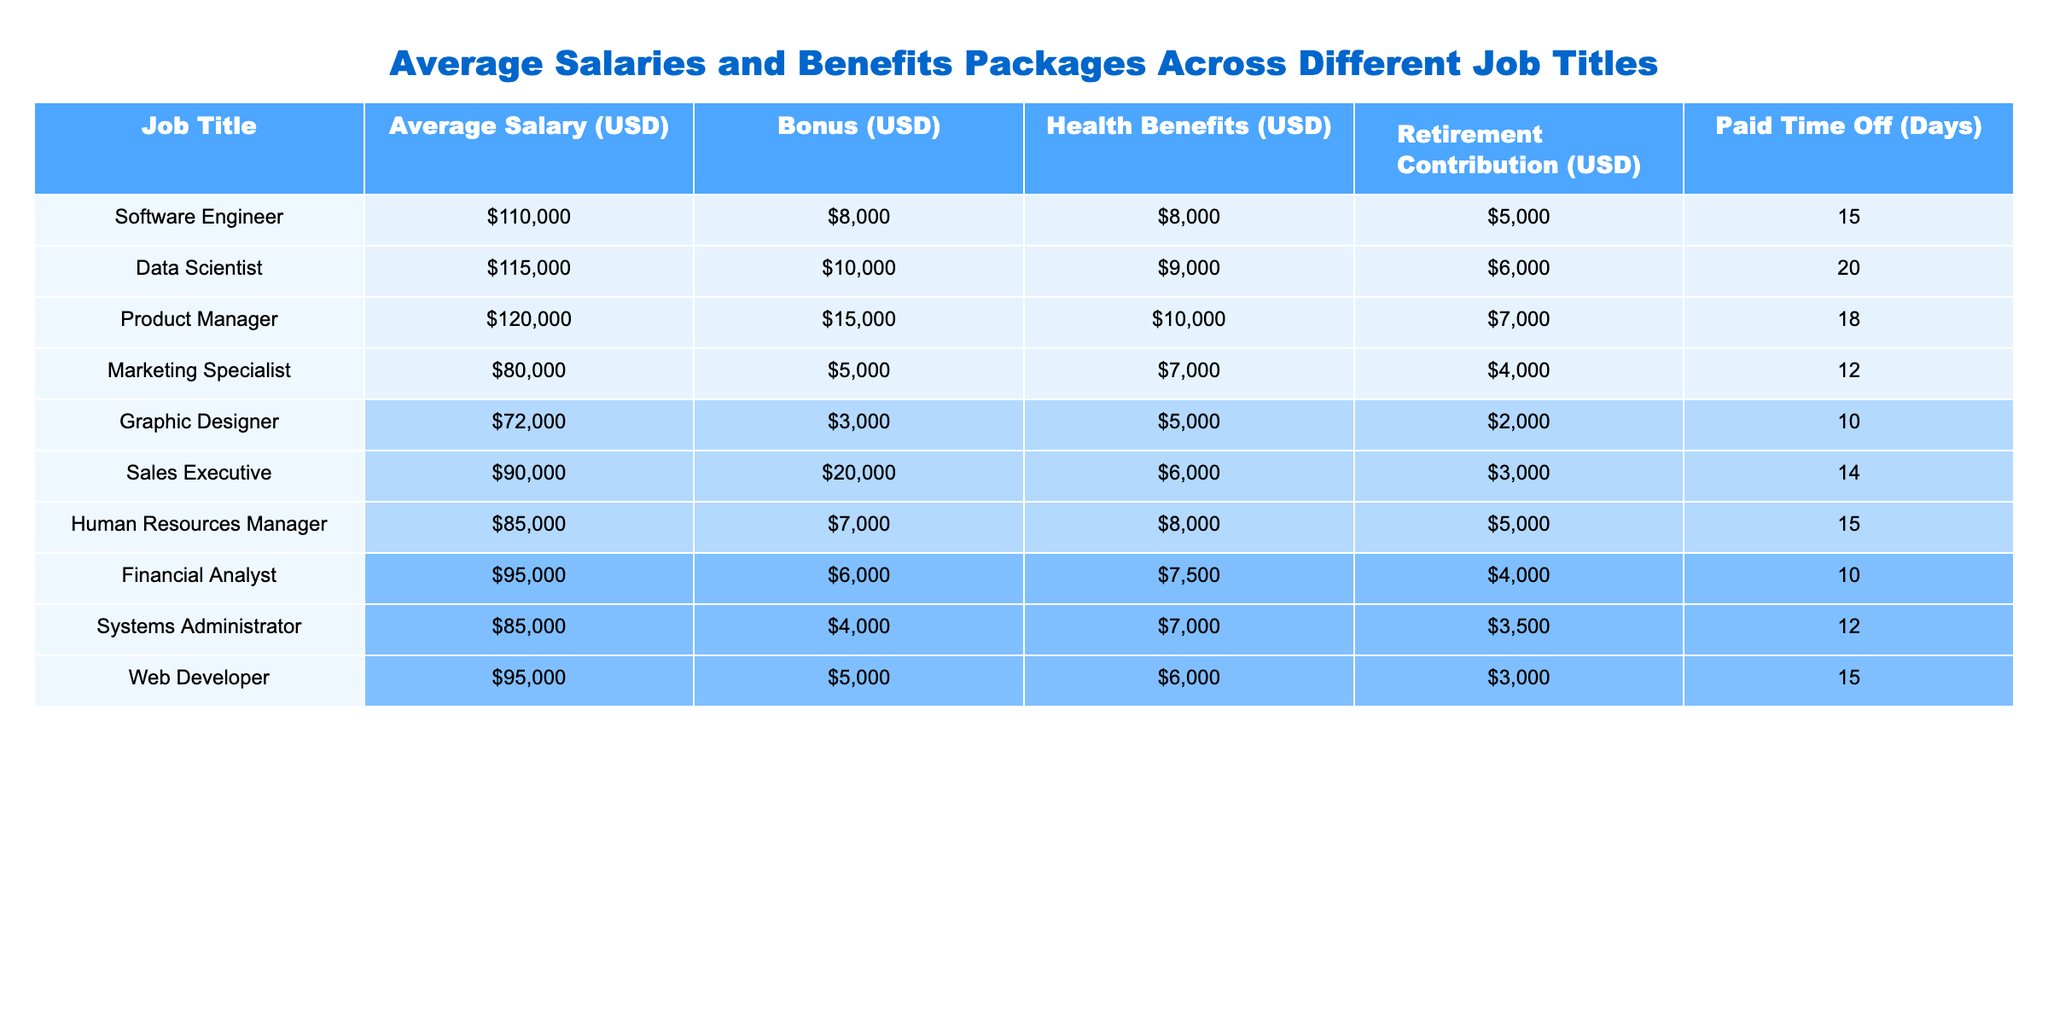What is the average salary of a Data Scientist? The table indicates that the average salary for a Data Scientist is listed directly under the "Average Salary (USD)" column. The value is 115000.
Answer: 115000 Which job title has the highest bonus? By comparing the "Bonus (USD)" column, the highest value is found under the "Sales Executive" job title, which is 20000.
Answer: Sales Executive How much retirement contribution does a Product Manager receive? The table shows that the retirement contribution for a Product Manager is located in the "Retirement Contribution (USD)" column, with the value being 7000.
Answer: 7000 Which job title has the least Paid Time Off? The "Paid Time Off (Days)" column is examined, and the least value is 10 days, corresponding to the "Graphic Designer" job title.
Answer: Graphic Designer What is the total combined average salary and bonus for a Software Engineer? The "Average Salary (USD)" for the Software Engineer is 110000, and the "Bonus (USD)" is 8000. Adding these values gives 110000 + 8000 = 118000.
Answer: 118000 How much more does a Data Scientist earn on average compared to a Marketing Specialist? The average salary for a Data Scientist is 115000, and for a Marketing Specialist, it is 80000. The difference is calculated as 115000 - 80000 = 35000.
Answer: 35000 Is the average salary for a Systems Administrator greater than the average salary for a Human Resources Manager? Checking the average salaries from the table, the Systems Administrator earns 85000, and the Human Resources Manager earns 85000 as well. Thus, they are equal.
Answer: No What is the average salary of the top three highest-paying job titles? The top three job titles based on the "Average Salary (USD)" are Product Manager (120000), Data Scientist (115000), and Software Engineer (110000). The average salary is calculated by summing these values and dividing by 3: (120000 + 115000 + 110000) / 3 = 115000.
Answer: 115000 How many days of Paid Time Off does a Financial Analyst receive? The "Paid Time Off (Days)" column reveals that the Financial Analyst receives 10 days of Paid Time Off.
Answer: 10 Which job title has a higher salary, Human Resources Manager or Marketing Specialist, and by how much? The average salary for a Human Resources Manager is 85000, while for a Marketing Specialist, it's 80000. The difference is 85000 - 80000 = 5000. Therefore, Human Resources Manager has a higher salary.
Answer: 5000 